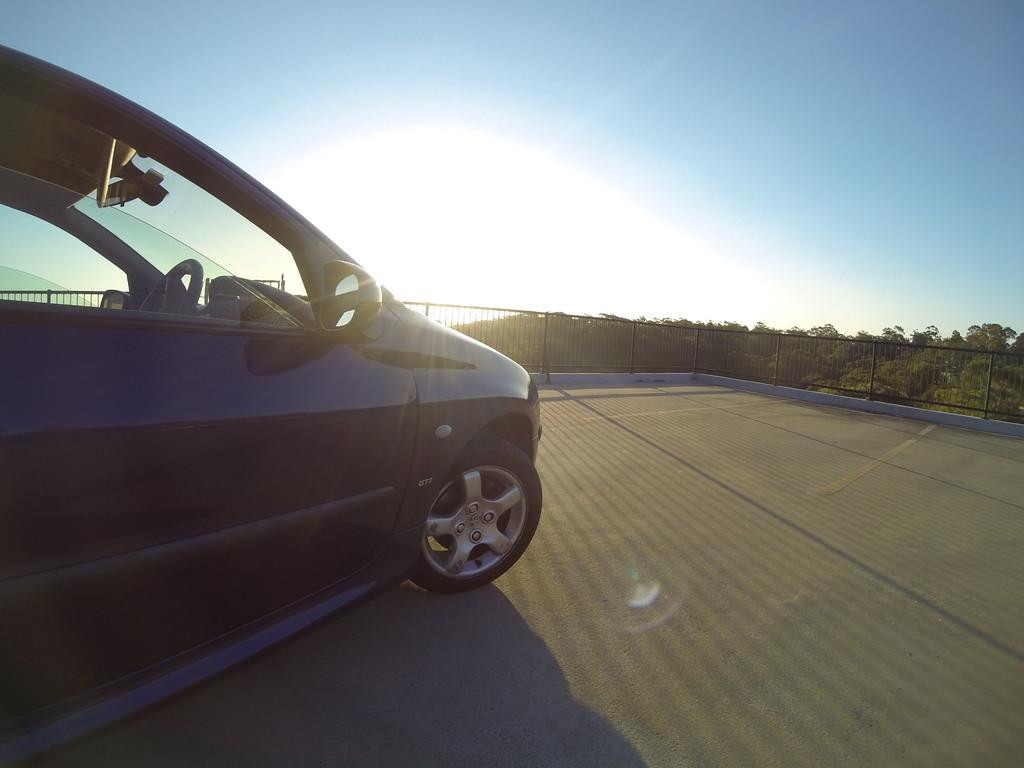What types of objects are present in the image? There are vehicles in the image. What kind of barrier can be seen in the image? There is fencing in the image. What type of natural elements are visible in the image? There are trees in the image. What is the color of the sky in the image? The sky is blue and white in color. How many knots are tied in the trees in the image? There are no knots present in the image, as it features vehicles, fencing, trees, and a blue and white sky. 